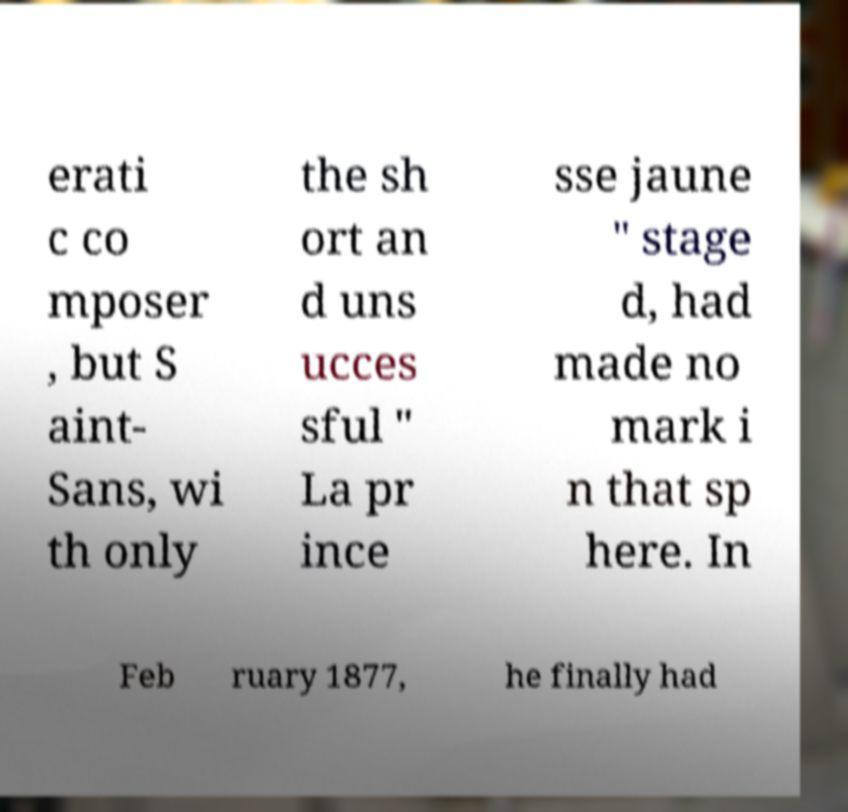Can you accurately transcribe the text from the provided image for me? erati c co mposer , but S aint- Sans, wi th only the sh ort an d uns ucces sful " La pr ince sse jaune " stage d, had made no mark i n that sp here. In Feb ruary 1877, he finally had 